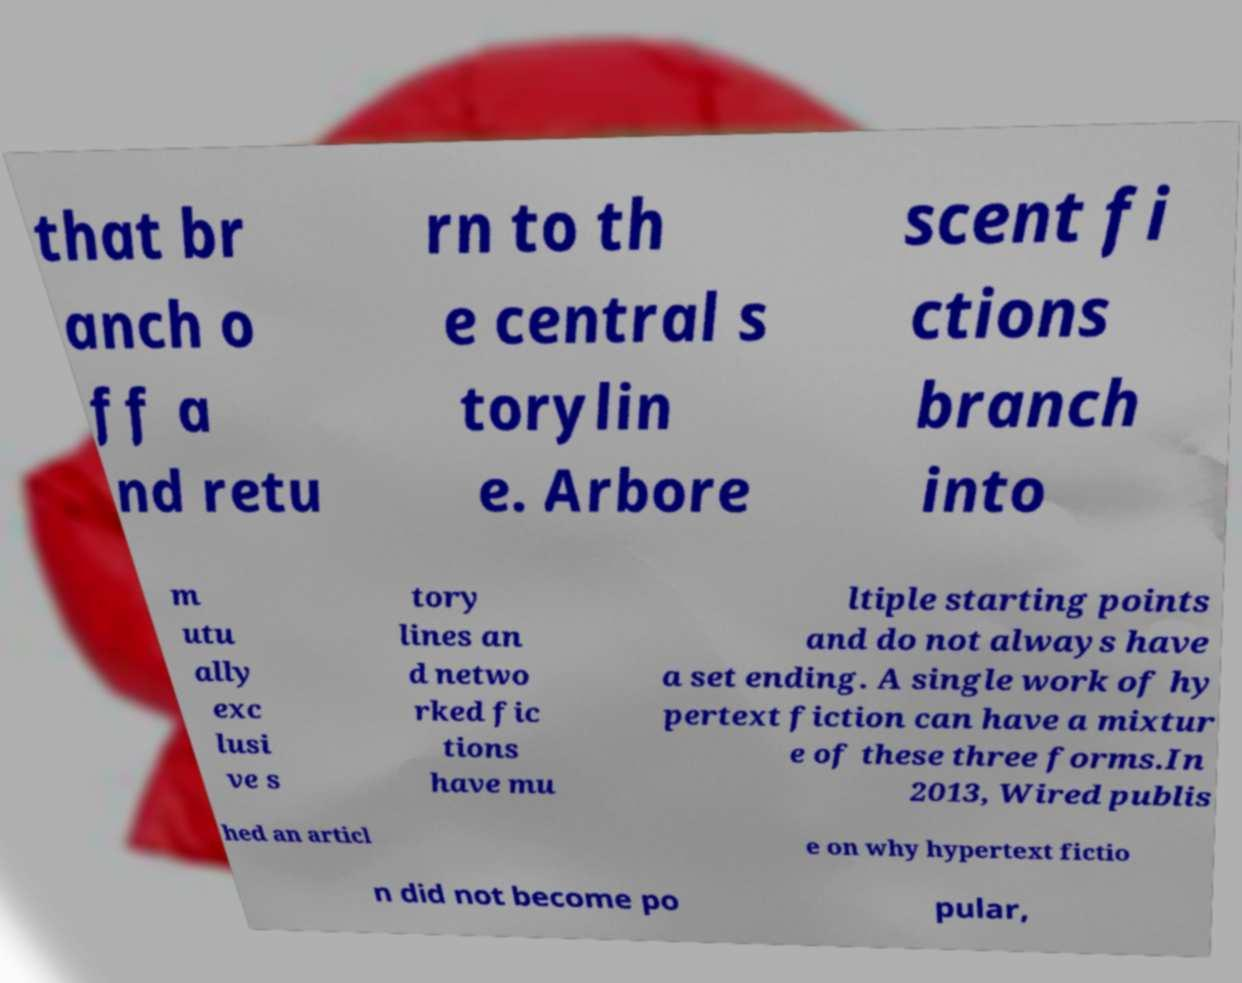For documentation purposes, I need the text within this image transcribed. Could you provide that? that br anch o ff a nd retu rn to th e central s torylin e. Arbore scent fi ctions branch into m utu ally exc lusi ve s tory lines an d netwo rked fic tions have mu ltiple starting points and do not always have a set ending. A single work of hy pertext fiction can have a mixtur e of these three forms.In 2013, Wired publis hed an articl e on why hypertext fictio n did not become po pular, 